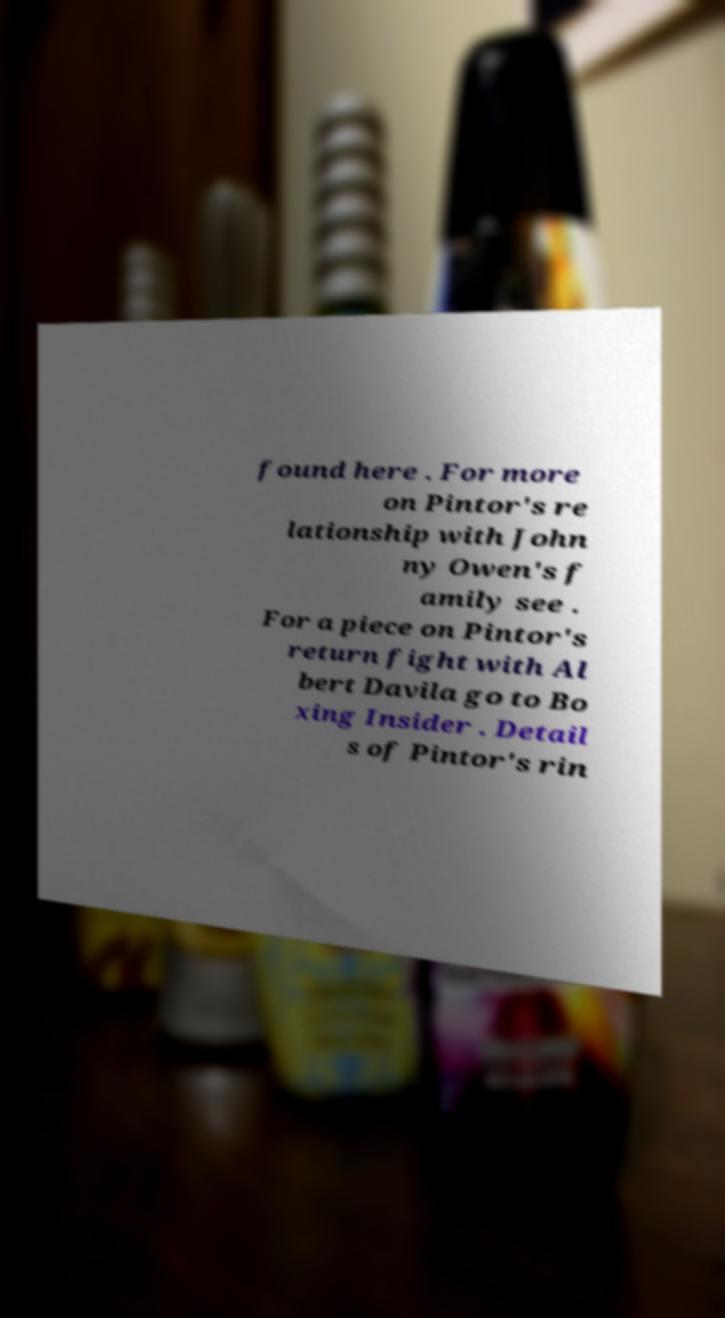I need the written content from this picture converted into text. Can you do that? found here . For more on Pintor's re lationship with John ny Owen's f amily see . For a piece on Pintor's return fight with Al bert Davila go to Bo xing Insider . Detail s of Pintor's rin 